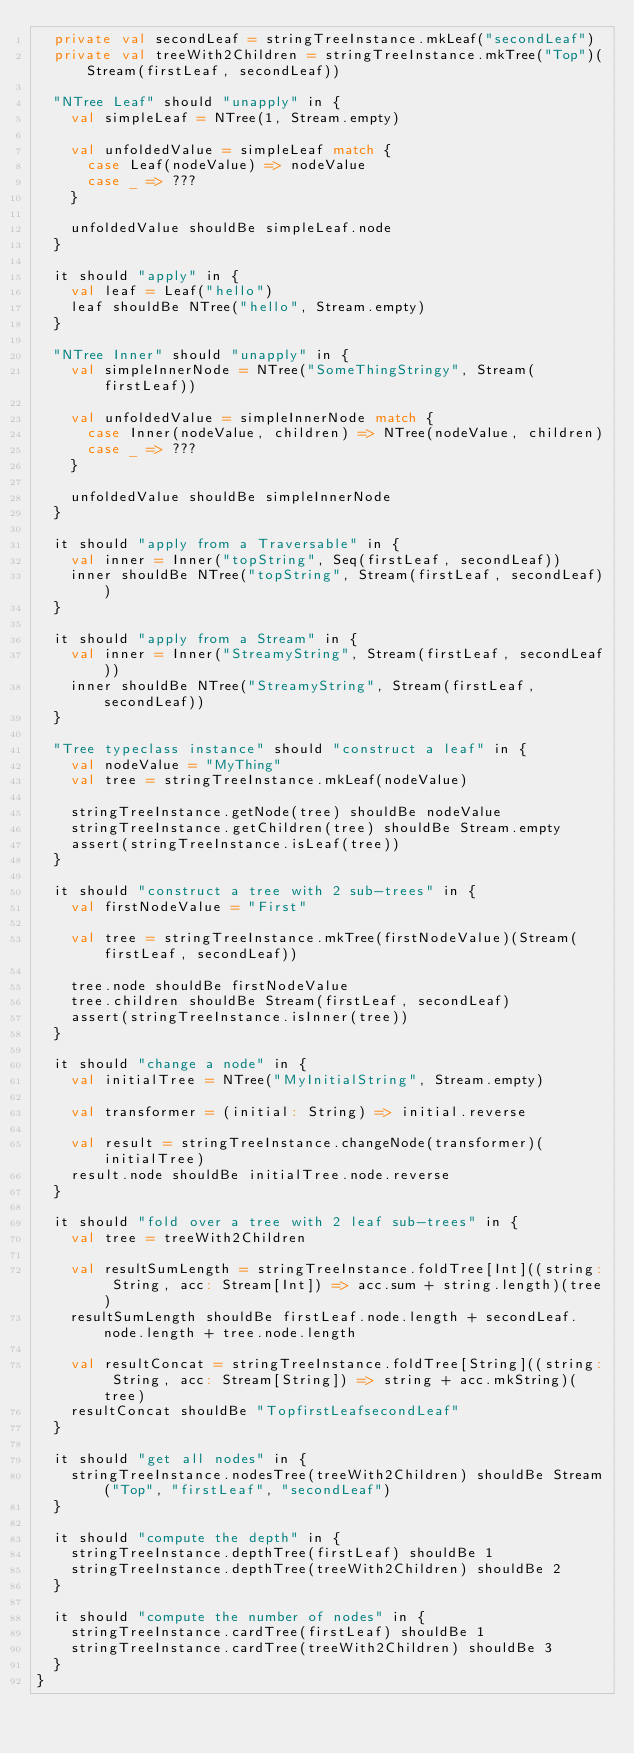Convert code to text. <code><loc_0><loc_0><loc_500><loc_500><_Scala_>  private val secondLeaf = stringTreeInstance.mkLeaf("secondLeaf")
  private val treeWith2Children = stringTreeInstance.mkTree("Top")(Stream(firstLeaf, secondLeaf))

  "NTree Leaf" should "unapply" in {
    val simpleLeaf = NTree(1, Stream.empty)

    val unfoldedValue = simpleLeaf match {
      case Leaf(nodeValue) => nodeValue
      case _ => ???
    }

    unfoldedValue shouldBe simpleLeaf.node
  }

  it should "apply" in {
    val leaf = Leaf("hello")
    leaf shouldBe NTree("hello", Stream.empty)
  }

  "NTree Inner" should "unapply" in {
    val simpleInnerNode = NTree("SomeThingStringy", Stream(firstLeaf))

    val unfoldedValue = simpleInnerNode match {
      case Inner(nodeValue, children) => NTree(nodeValue, children)
      case _ => ???
    }

    unfoldedValue shouldBe simpleInnerNode
  }

  it should "apply from a Traversable" in {
    val inner = Inner("topString", Seq(firstLeaf, secondLeaf))
    inner shouldBe NTree("topString", Stream(firstLeaf, secondLeaf))
  }

  it should "apply from a Stream" in {
    val inner = Inner("StreamyString", Stream(firstLeaf, secondLeaf))
    inner shouldBe NTree("StreamyString", Stream(firstLeaf, secondLeaf))
  }

  "Tree typeclass instance" should "construct a leaf" in {
    val nodeValue = "MyThing"
    val tree = stringTreeInstance.mkLeaf(nodeValue)

    stringTreeInstance.getNode(tree) shouldBe nodeValue
    stringTreeInstance.getChildren(tree) shouldBe Stream.empty
    assert(stringTreeInstance.isLeaf(tree))
  }

  it should "construct a tree with 2 sub-trees" in {
    val firstNodeValue = "First"

    val tree = stringTreeInstance.mkTree(firstNodeValue)(Stream(firstLeaf, secondLeaf))

    tree.node shouldBe firstNodeValue
    tree.children shouldBe Stream(firstLeaf, secondLeaf)
    assert(stringTreeInstance.isInner(tree))
  }

  it should "change a node" in {
    val initialTree = NTree("MyInitialString", Stream.empty)

    val transformer = (initial: String) => initial.reverse

    val result = stringTreeInstance.changeNode(transformer)(initialTree)
    result.node shouldBe initialTree.node.reverse
  }

  it should "fold over a tree with 2 leaf sub-trees" in {
    val tree = treeWith2Children

    val resultSumLength = stringTreeInstance.foldTree[Int]((string: String, acc: Stream[Int]) => acc.sum + string.length)(tree)
    resultSumLength shouldBe firstLeaf.node.length + secondLeaf.node.length + tree.node.length

    val resultConcat = stringTreeInstance.foldTree[String]((string: String, acc: Stream[String]) => string + acc.mkString)(tree)
    resultConcat shouldBe "TopfirstLeafsecondLeaf"
  }

  it should "get all nodes" in {
    stringTreeInstance.nodesTree(treeWith2Children) shouldBe Stream("Top", "firstLeaf", "secondLeaf")
  }

  it should "compute the depth" in {
    stringTreeInstance.depthTree(firstLeaf) shouldBe 1
    stringTreeInstance.depthTree(treeWith2Children) shouldBe 2
  }

  it should "compute the number of nodes" in {
    stringTreeInstance.cardTree(firstLeaf) shouldBe 1
    stringTreeInstance.cardTree(treeWith2Children) shouldBe 3
  }
}
</code> 